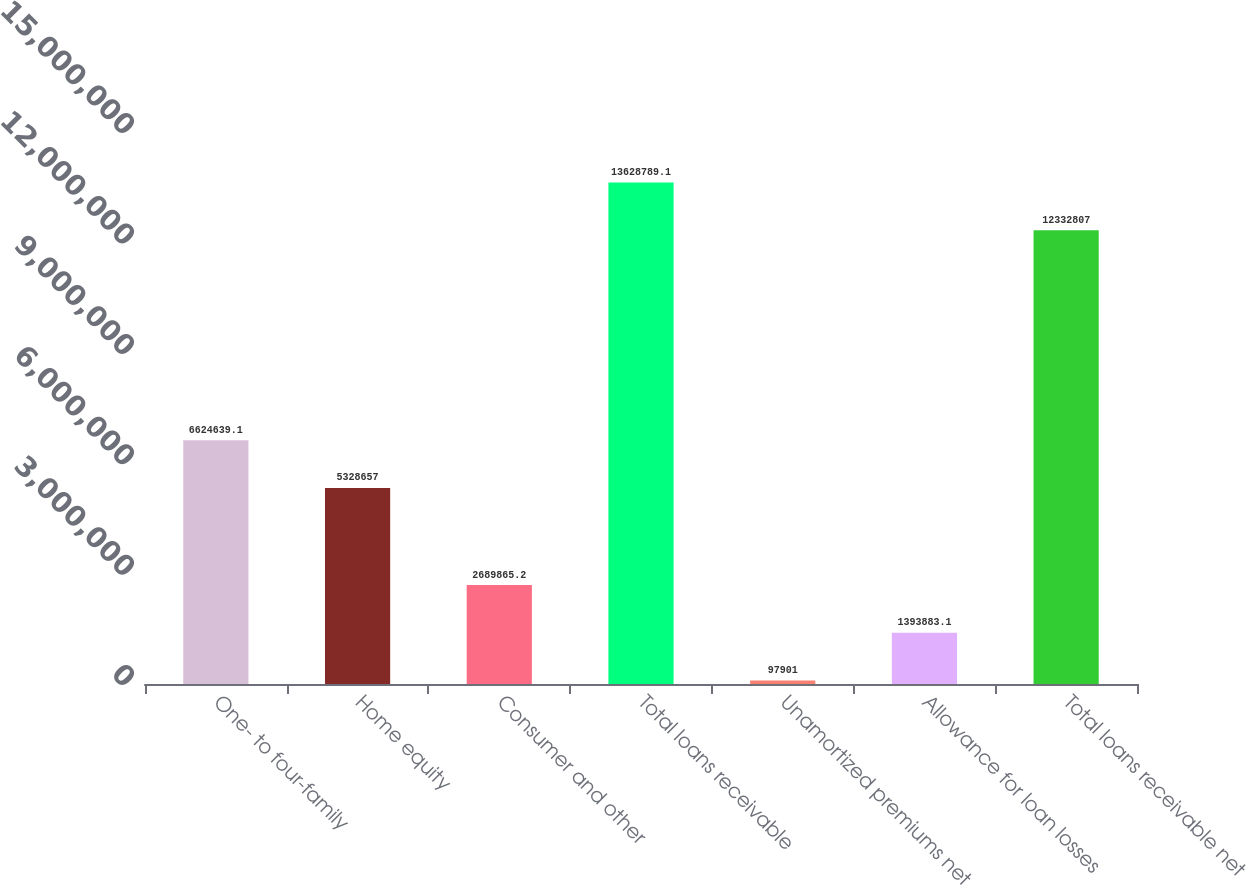Convert chart. <chart><loc_0><loc_0><loc_500><loc_500><bar_chart><fcel>One- to four-family<fcel>Home equity<fcel>Consumer and other<fcel>Total loans receivable<fcel>Unamortized premiums net<fcel>Allowance for loan losses<fcel>Total loans receivable net<nl><fcel>6.62464e+06<fcel>5.32866e+06<fcel>2.68987e+06<fcel>1.36288e+07<fcel>97901<fcel>1.39388e+06<fcel>1.23328e+07<nl></chart> 